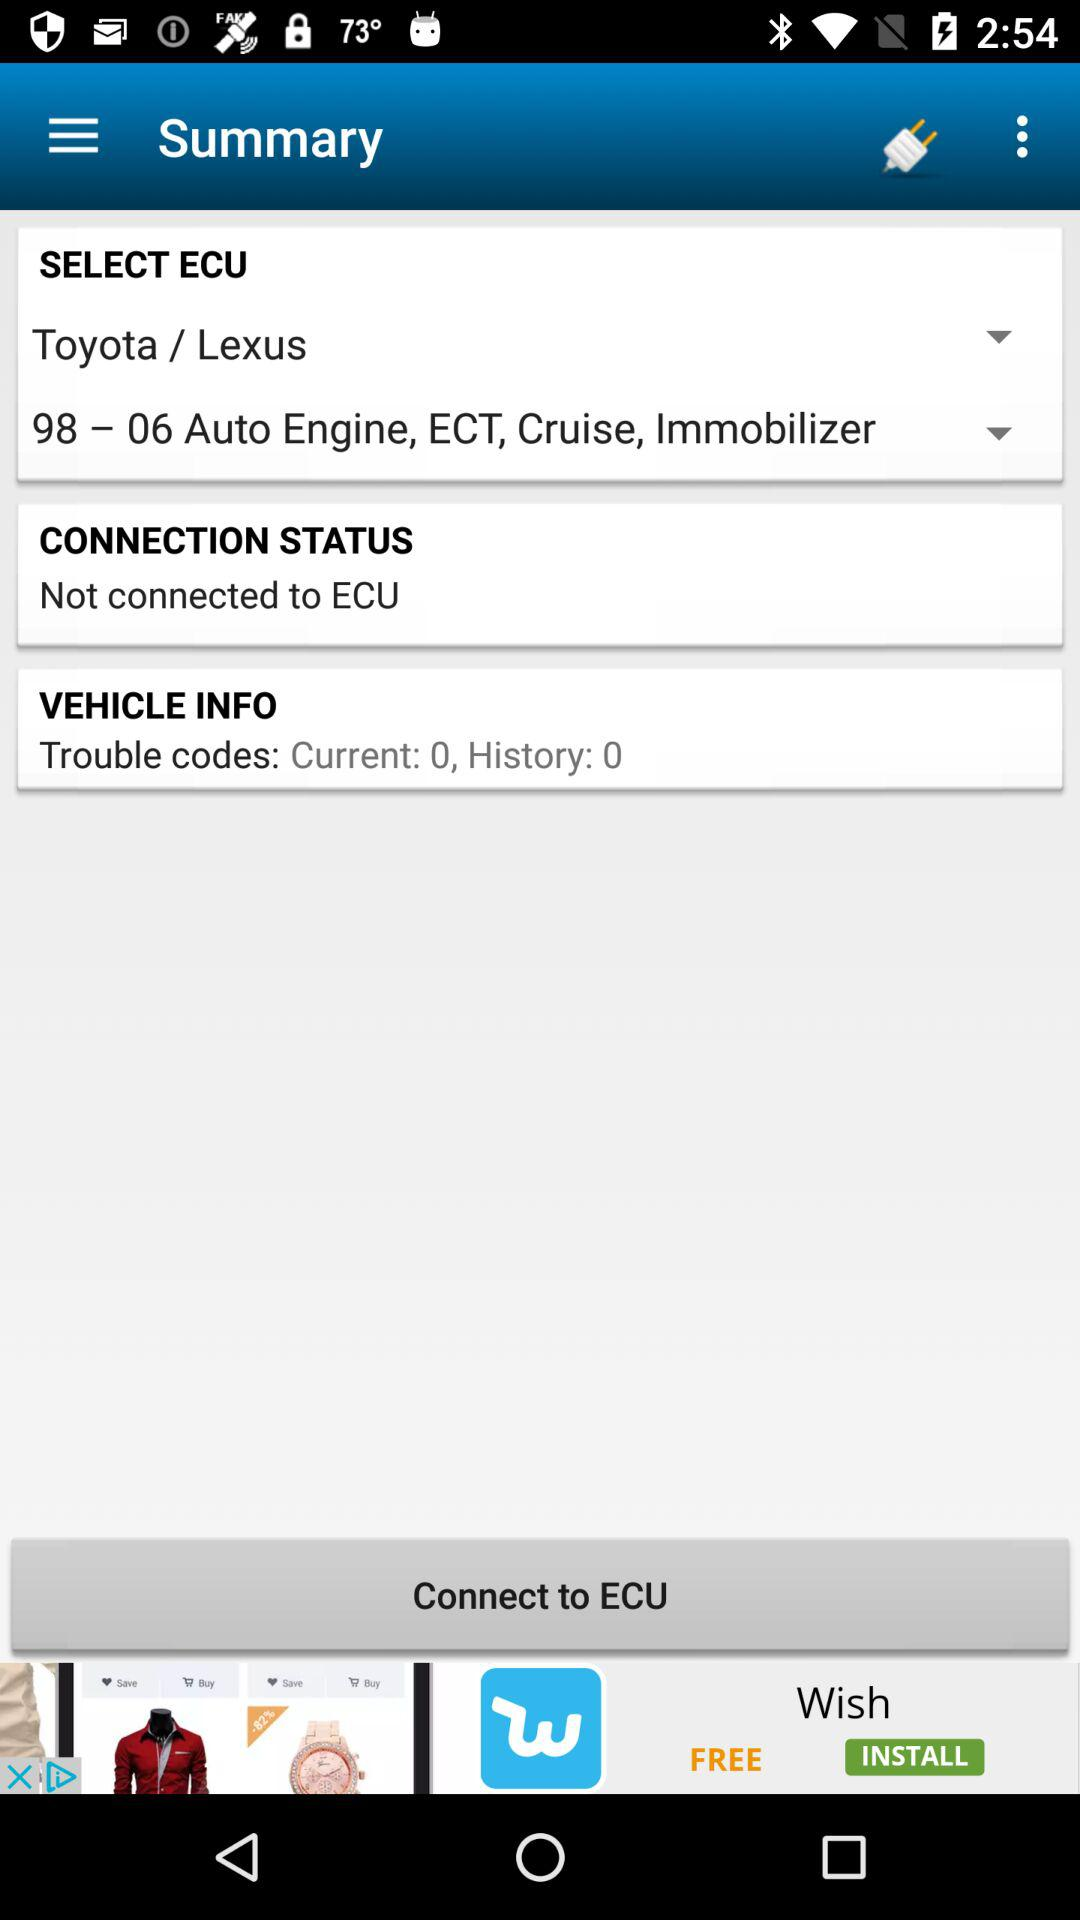What is the current count of Trouble codes in "VEHICLE INFO"? The count is 0. 